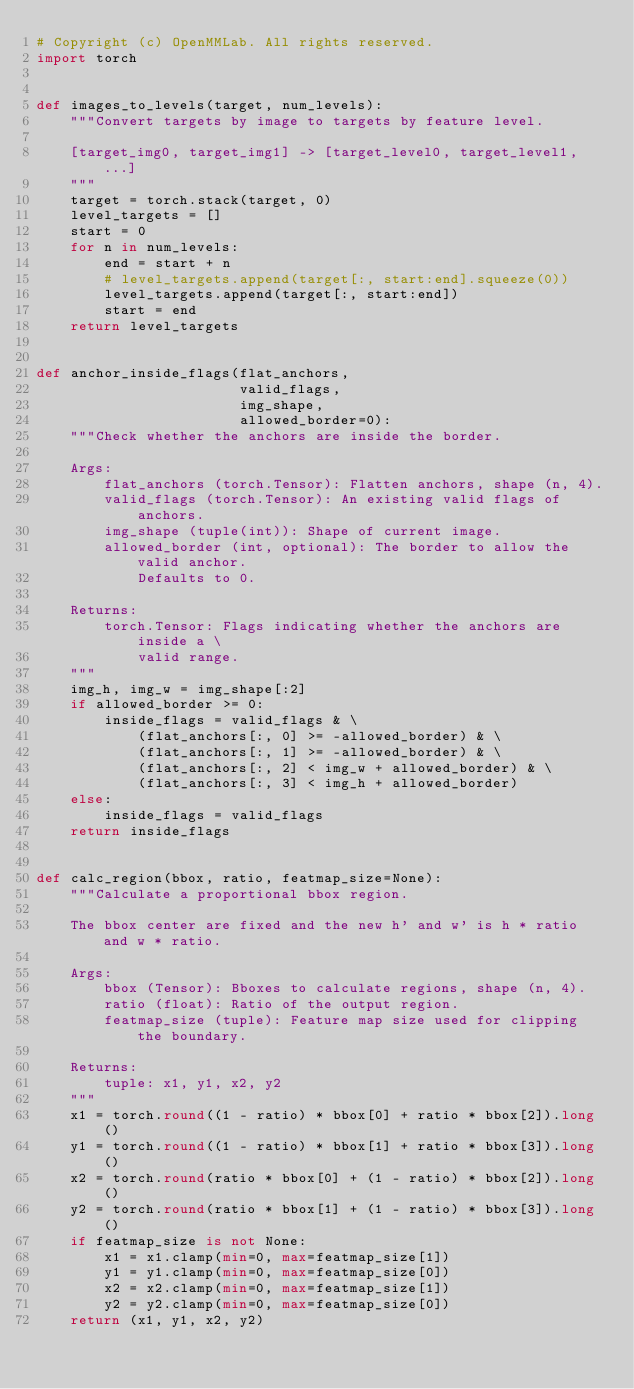<code> <loc_0><loc_0><loc_500><loc_500><_Python_># Copyright (c) OpenMMLab. All rights reserved.
import torch


def images_to_levels(target, num_levels):
    """Convert targets by image to targets by feature level.

    [target_img0, target_img1] -> [target_level0, target_level1, ...]
    """
    target = torch.stack(target, 0)
    level_targets = []
    start = 0
    for n in num_levels:
        end = start + n
        # level_targets.append(target[:, start:end].squeeze(0))
        level_targets.append(target[:, start:end])
        start = end
    return level_targets


def anchor_inside_flags(flat_anchors,
                        valid_flags,
                        img_shape,
                        allowed_border=0):
    """Check whether the anchors are inside the border.

    Args:
        flat_anchors (torch.Tensor): Flatten anchors, shape (n, 4).
        valid_flags (torch.Tensor): An existing valid flags of anchors.
        img_shape (tuple(int)): Shape of current image.
        allowed_border (int, optional): The border to allow the valid anchor.
            Defaults to 0.

    Returns:
        torch.Tensor: Flags indicating whether the anchors are inside a \
            valid range.
    """
    img_h, img_w = img_shape[:2]
    if allowed_border >= 0:
        inside_flags = valid_flags & \
            (flat_anchors[:, 0] >= -allowed_border) & \
            (flat_anchors[:, 1] >= -allowed_border) & \
            (flat_anchors[:, 2] < img_w + allowed_border) & \
            (flat_anchors[:, 3] < img_h + allowed_border)
    else:
        inside_flags = valid_flags
    return inside_flags


def calc_region(bbox, ratio, featmap_size=None):
    """Calculate a proportional bbox region.

    The bbox center are fixed and the new h' and w' is h * ratio and w * ratio.

    Args:
        bbox (Tensor): Bboxes to calculate regions, shape (n, 4).
        ratio (float): Ratio of the output region.
        featmap_size (tuple): Feature map size used for clipping the boundary.

    Returns:
        tuple: x1, y1, x2, y2
    """
    x1 = torch.round((1 - ratio) * bbox[0] + ratio * bbox[2]).long()
    y1 = torch.round((1 - ratio) * bbox[1] + ratio * bbox[3]).long()
    x2 = torch.round(ratio * bbox[0] + (1 - ratio) * bbox[2]).long()
    y2 = torch.round(ratio * bbox[1] + (1 - ratio) * bbox[3]).long()
    if featmap_size is not None:
        x1 = x1.clamp(min=0, max=featmap_size[1])
        y1 = y1.clamp(min=0, max=featmap_size[0])
        x2 = x2.clamp(min=0, max=featmap_size[1])
        y2 = y2.clamp(min=0, max=featmap_size[0])
    return (x1, y1, x2, y2)
</code> 